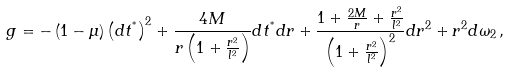<formula> <loc_0><loc_0><loc_500><loc_500>g = - \left ( 1 - \mu \right ) \left ( d t ^ { ^ { * } } \right ) ^ { 2 } + \frac { 4 M } { r \left ( 1 + \frac { r ^ { 2 } } { l ^ { 2 } } \right ) } d t ^ { ^ { * } } d r + \frac { 1 + \frac { 2 M } { r } + \frac { r ^ { 2 } } { l ^ { 2 } } } { \left ( 1 + \frac { r ^ { 2 } } { l ^ { 2 } } \right ) ^ { 2 } } d r ^ { 2 } + r ^ { 2 } d \omega _ { 2 } \, ,</formula> 